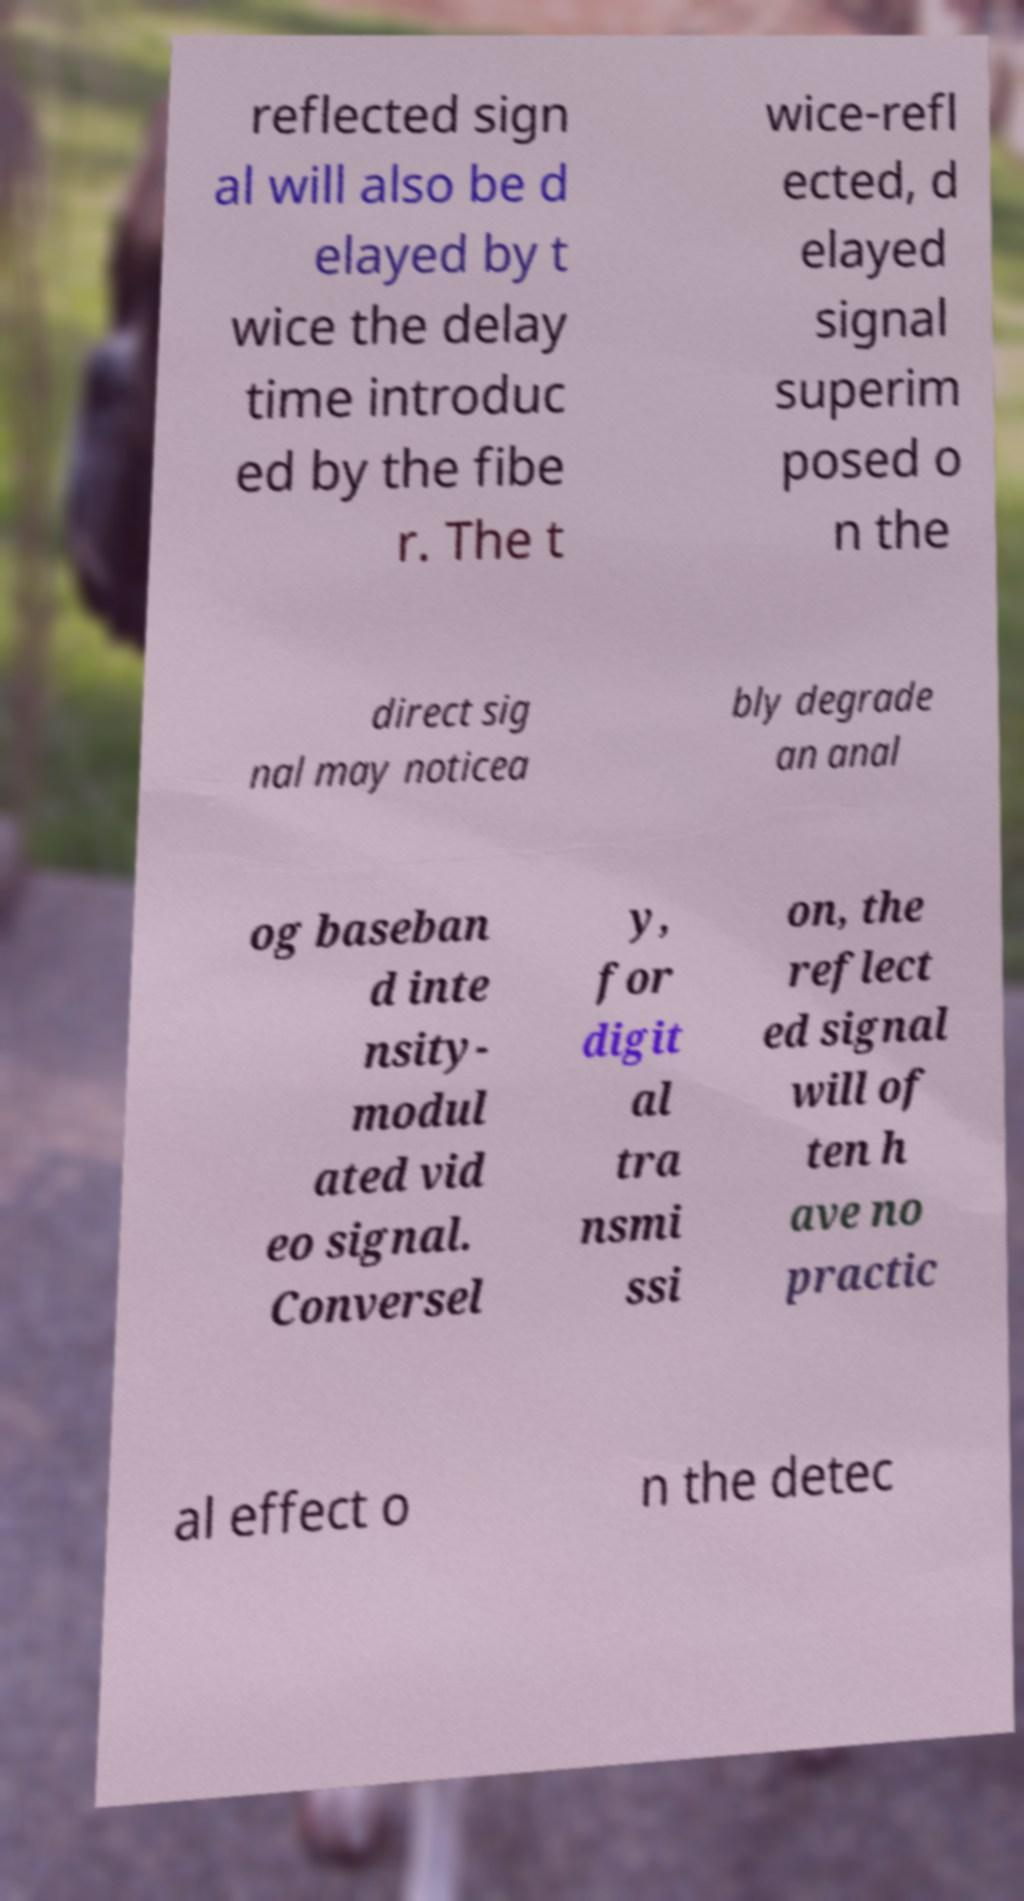Can you read and provide the text displayed in the image?This photo seems to have some interesting text. Can you extract and type it out for me? reflected sign al will also be d elayed by t wice the delay time introduc ed by the fibe r. The t wice-refl ected, d elayed signal superim posed o n the direct sig nal may noticea bly degrade an anal og baseban d inte nsity- modul ated vid eo signal. Conversel y, for digit al tra nsmi ssi on, the reflect ed signal will of ten h ave no practic al effect o n the detec 